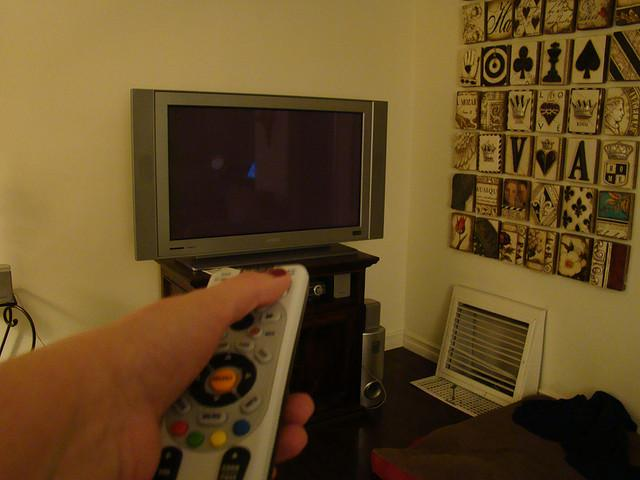What does this person want to do?

Choices:
A) pay cashier
B) make dinner
C) change channel
D) take shower change channel 